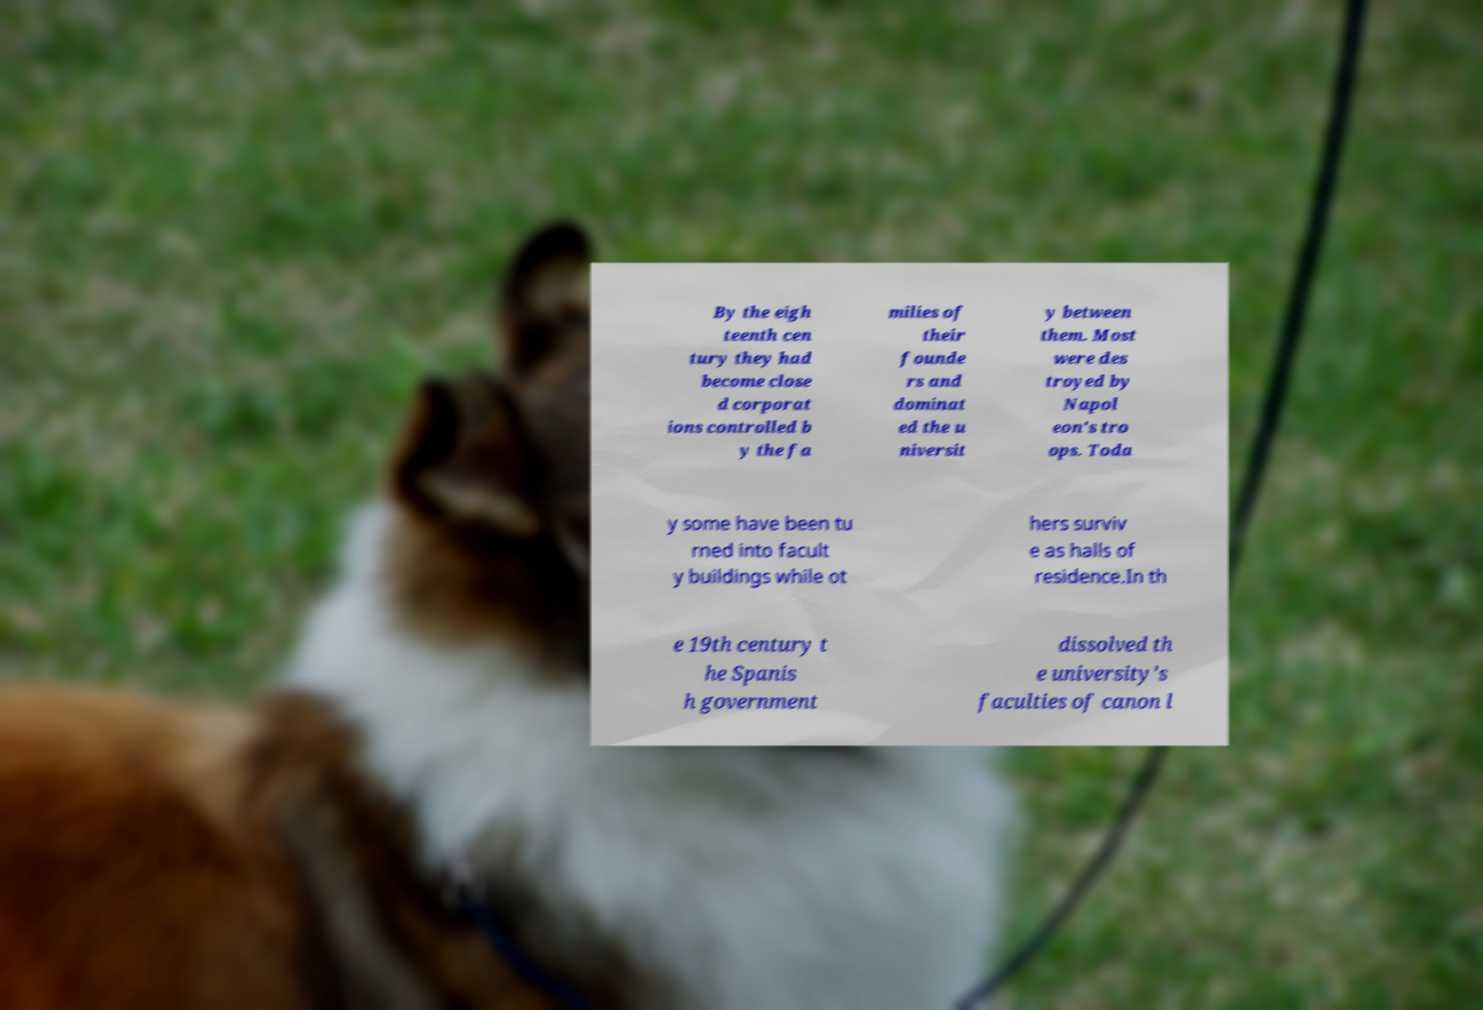Please read and relay the text visible in this image. What does it say? By the eigh teenth cen tury they had become close d corporat ions controlled b y the fa milies of their founde rs and dominat ed the u niversit y between them. Most were des troyed by Napol eon's tro ops. Toda y some have been tu rned into facult y buildings while ot hers surviv e as halls of residence.In th e 19th century t he Spanis h government dissolved th e university's faculties of canon l 